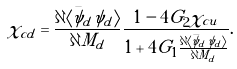Convert formula to latex. <formula><loc_0><loc_0><loc_500><loc_500>\chi _ { c d } = \frac { \partial \langle \bar { \psi } _ { d } \psi _ { d } \rangle } { \partial M _ { d } } \frac { 1 - 4 G _ { 2 } \chi _ { c u } } { 1 + 4 G _ { 1 } \frac { \partial \langle \bar { \psi } _ { d } \psi _ { d } \rangle } { \partial M _ { d } } } .</formula> 